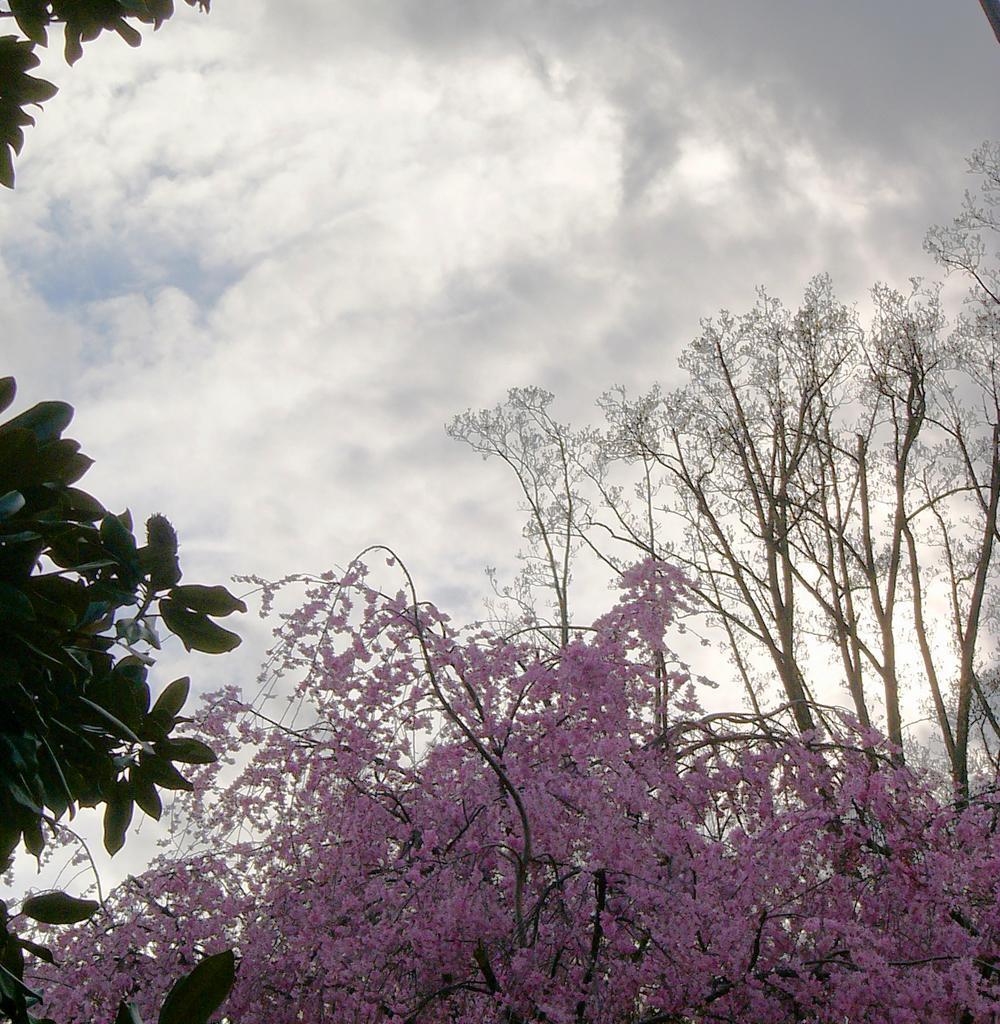In one or two sentences, can you explain what this image depicts? In this picture I can see a tree with pink flowers, there are trees, and in the background there is sky. 